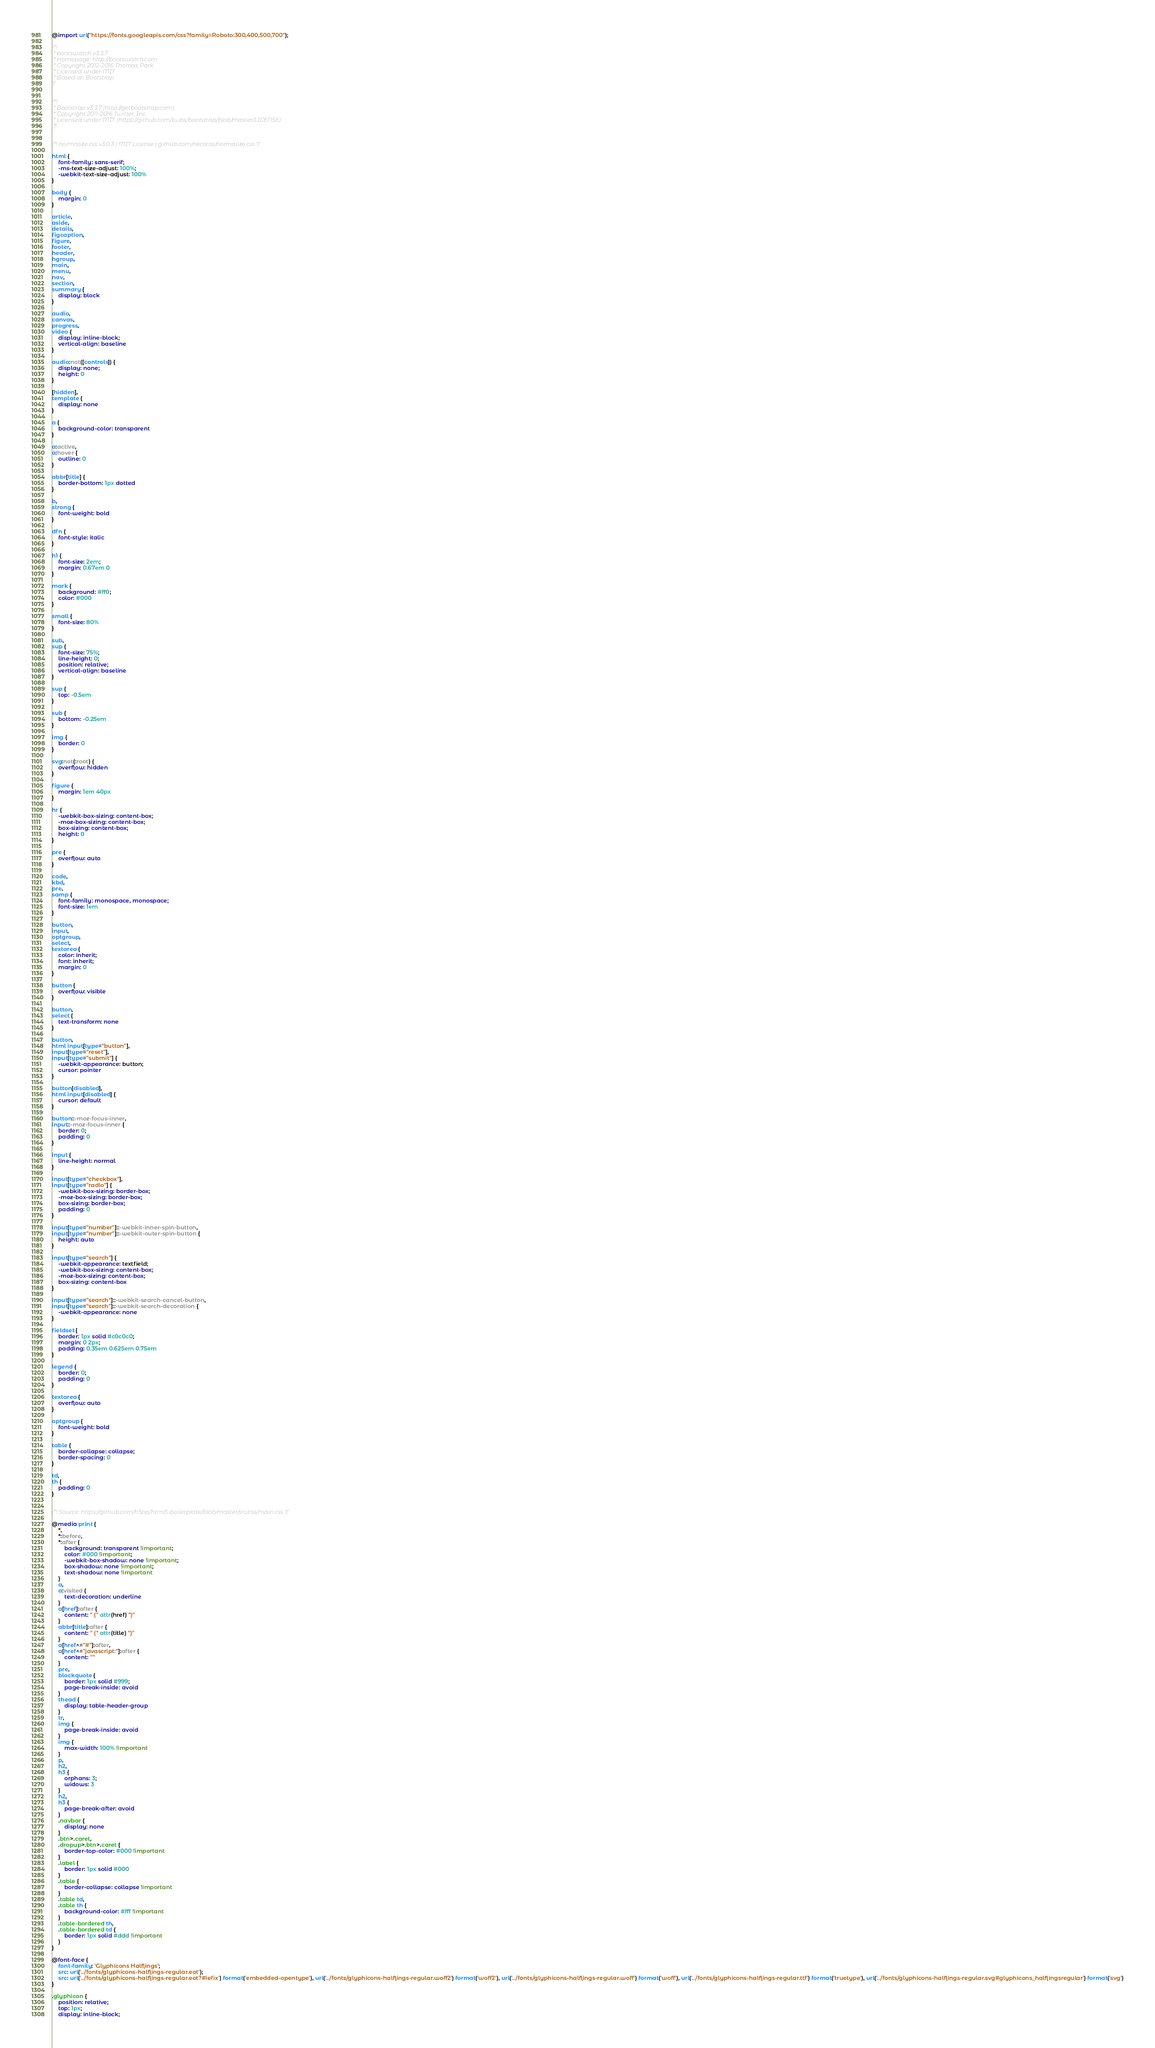Convert code to text. <code><loc_0><loc_0><loc_500><loc_500><_CSS_>@import url("https://fonts.googleapis.com/css?family=Roboto:300,400,500,700");

/*!
 * bootswatch v3.3.7
 * Homepage: http://bootswatch.com
 * Copyright 2012-2016 Thomas Park
 * Licensed under MIT
 * Based on Bootstrap
*/


/*!
 * Bootstrap v3.3.7 (http://getbootstrap.com)
 * Copyright 2011-2016 Twitter, Inc.
 * Licensed under MIT (https://github.com/twbs/bootstrap/blob/master/LICENSE)
 */


/*! normalize.css v3.0.3 | MIT License | github.com/necolas/normalize.css */

html {
    font-family: sans-serif;
    -ms-text-size-adjust: 100%;
    -webkit-text-size-adjust: 100%
}

body {
    margin: 0
}

article,
aside,
details,
figcaption,
figure,
footer,
header,
hgroup,
main,
menu,
nav,
section,
summary {
    display: block
}

audio,
canvas,
progress,
video {
    display: inline-block;
    vertical-align: baseline
}

audio:not([controls]) {
    display: none;
    height: 0
}

[hidden],
template {
    display: none
}

a {
    background-color: transparent
}

a:active,
a:hover {
    outline: 0
}

abbr[title] {
    border-bottom: 1px dotted
}

b,
strong {
    font-weight: bold
}

dfn {
    font-style: italic
}

h1 {
    font-size: 2em;
    margin: 0.67em 0
}

mark {
    background: #ff0;
    color: #000
}

small {
    font-size: 80%
}

sub,
sup {
    font-size: 75%;
    line-height: 0;
    position: relative;
    vertical-align: baseline
}

sup {
    top: -0.5em
}

sub {
    bottom: -0.25em
}

img {
    border: 0
}

svg:not(:root) {
    overflow: hidden
}

figure {
    margin: 1em 40px
}

hr {
    -webkit-box-sizing: content-box;
    -moz-box-sizing: content-box;
    box-sizing: content-box;
    height: 0
}

pre {
    overflow: auto
}

code,
kbd,
pre,
samp {
    font-family: monospace, monospace;
    font-size: 1em
}

button,
input,
optgroup,
select,
textarea {
    color: inherit;
    font: inherit;
    margin: 0
}

button {
    overflow: visible
}

button,
select {
    text-transform: none
}

button,
html input[type="button"],
input[type="reset"],
input[type="submit"] {
    -webkit-appearance: button;
    cursor: pointer
}

button[disabled],
html input[disabled] {
    cursor: default
}

button::-moz-focus-inner,
input::-moz-focus-inner {
    border: 0;
    padding: 0
}

input {
    line-height: normal
}

input[type="checkbox"],
input[type="radio"] {
    -webkit-box-sizing: border-box;
    -moz-box-sizing: border-box;
    box-sizing: border-box;
    padding: 0
}

input[type="number"]::-webkit-inner-spin-button,
input[type="number"]::-webkit-outer-spin-button {
    height: auto
}

input[type="search"] {
    -webkit-appearance: textfield;
    -webkit-box-sizing: content-box;
    -moz-box-sizing: content-box;
    box-sizing: content-box
}

input[type="search"]::-webkit-search-cancel-button,
input[type="search"]::-webkit-search-decoration {
    -webkit-appearance: none
}

fieldset {
    border: 1px solid #c0c0c0;
    margin: 0 2px;
    padding: 0.35em 0.625em 0.75em
}

legend {
    border: 0;
    padding: 0
}

textarea {
    overflow: auto
}

optgroup {
    font-weight: bold
}

table {
    border-collapse: collapse;
    border-spacing: 0
}

td,
th {
    padding: 0
}


/*! Source: https://github.com/h5bp/html5-boilerplate/blob/master/src/css/main.css */

@media print {
    *,
    *:before,
    *:after {
        background: transparent !important;
        color: #000 !important;
        -webkit-box-shadow: none !important;
        box-shadow: none !important;
        text-shadow: none !important
    }
    a,
    a:visited {
        text-decoration: underline
    }
    a[href]:after {
        content: " (" attr(href) ")"
    }
    abbr[title]:after {
        content: " (" attr(title) ")"
    }
    a[href^="#"]:after,
    a[href^="javascript:"]:after {
        content: ""
    }
    pre,
    blockquote {
        border: 1px solid #999;
        page-break-inside: avoid
    }
    thead {
        display: table-header-group
    }
    tr,
    img {
        page-break-inside: avoid
    }
    img {
        max-width: 100% !important
    }
    p,
    h2,
    h3 {
        orphans: 3;
        widows: 3
    }
    h2,
    h3 {
        page-break-after: avoid
    }
    .navbar {
        display: none
    }
    .btn>.caret,
    .dropup>.btn>.caret {
        border-top-color: #000 !important
    }
    .label {
        border: 1px solid #000
    }
    .table {
        border-collapse: collapse !important
    }
    .table td,
    .table th {
        background-color: #fff !important
    }
    .table-bordered th,
    .table-bordered td {
        border: 1px solid #ddd !important
    }
}

@font-face {
    font-family: 'Glyphicons Halflings';
    src: url('../fonts/glyphicons-halflings-regular.eot');
    src: url('../fonts/glyphicons-halflings-regular.eot?#iefix') format('embedded-opentype'), url('../fonts/glyphicons-halflings-regular.woff2') format('woff2'), url('../fonts/glyphicons-halflings-regular.woff') format('woff'), url('../fonts/glyphicons-halflings-regular.ttf') format('truetype'), url('../fonts/glyphicons-halflings-regular.svg#glyphicons_halflingsregular') format('svg')
}

.glyphicon {
    position: relative;
    top: 1px;
    display: inline-block;</code> 